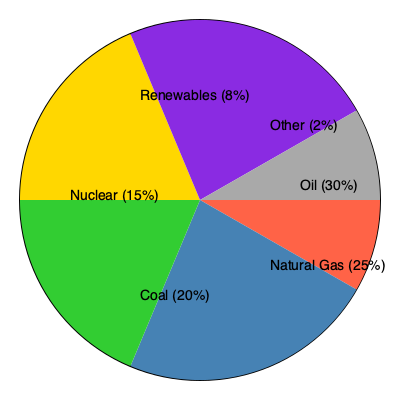Based on the pie chart showing energy sources and their market share, which combination of energy sources would be required to match the market share of oil? To solve this problem, we need to follow these steps:

1. Identify the market share of oil: 30%

2. List the market shares of other energy sources:
   - Natural Gas: 25%
   - Coal: 20%
   - Nuclear: 15%
   - Renewables: 8%
   - Other: 2%

3. Find a combination that adds up to 30%:
   - Coal (20%) + Renewables (8%) + Other (2%) = 30%

4. Verify that no other combination of two or three sources exactly matches 30%:
   - Natural Gas (25%) + Renewables (8%) ≠ 30%
   - Nuclear (15%) + Renewables (8%) + Other (2%) ≠ 30%

5. Conclude that Coal, Renewables, and Other combined equal the market share of oil.

This analysis demonstrates the importance of diversification in the energy sector and highlights the significant role that traditional fossil fuels still play in the energy mix, despite the growing importance of renewable sources.
Answer: Coal, Renewables, and Other 